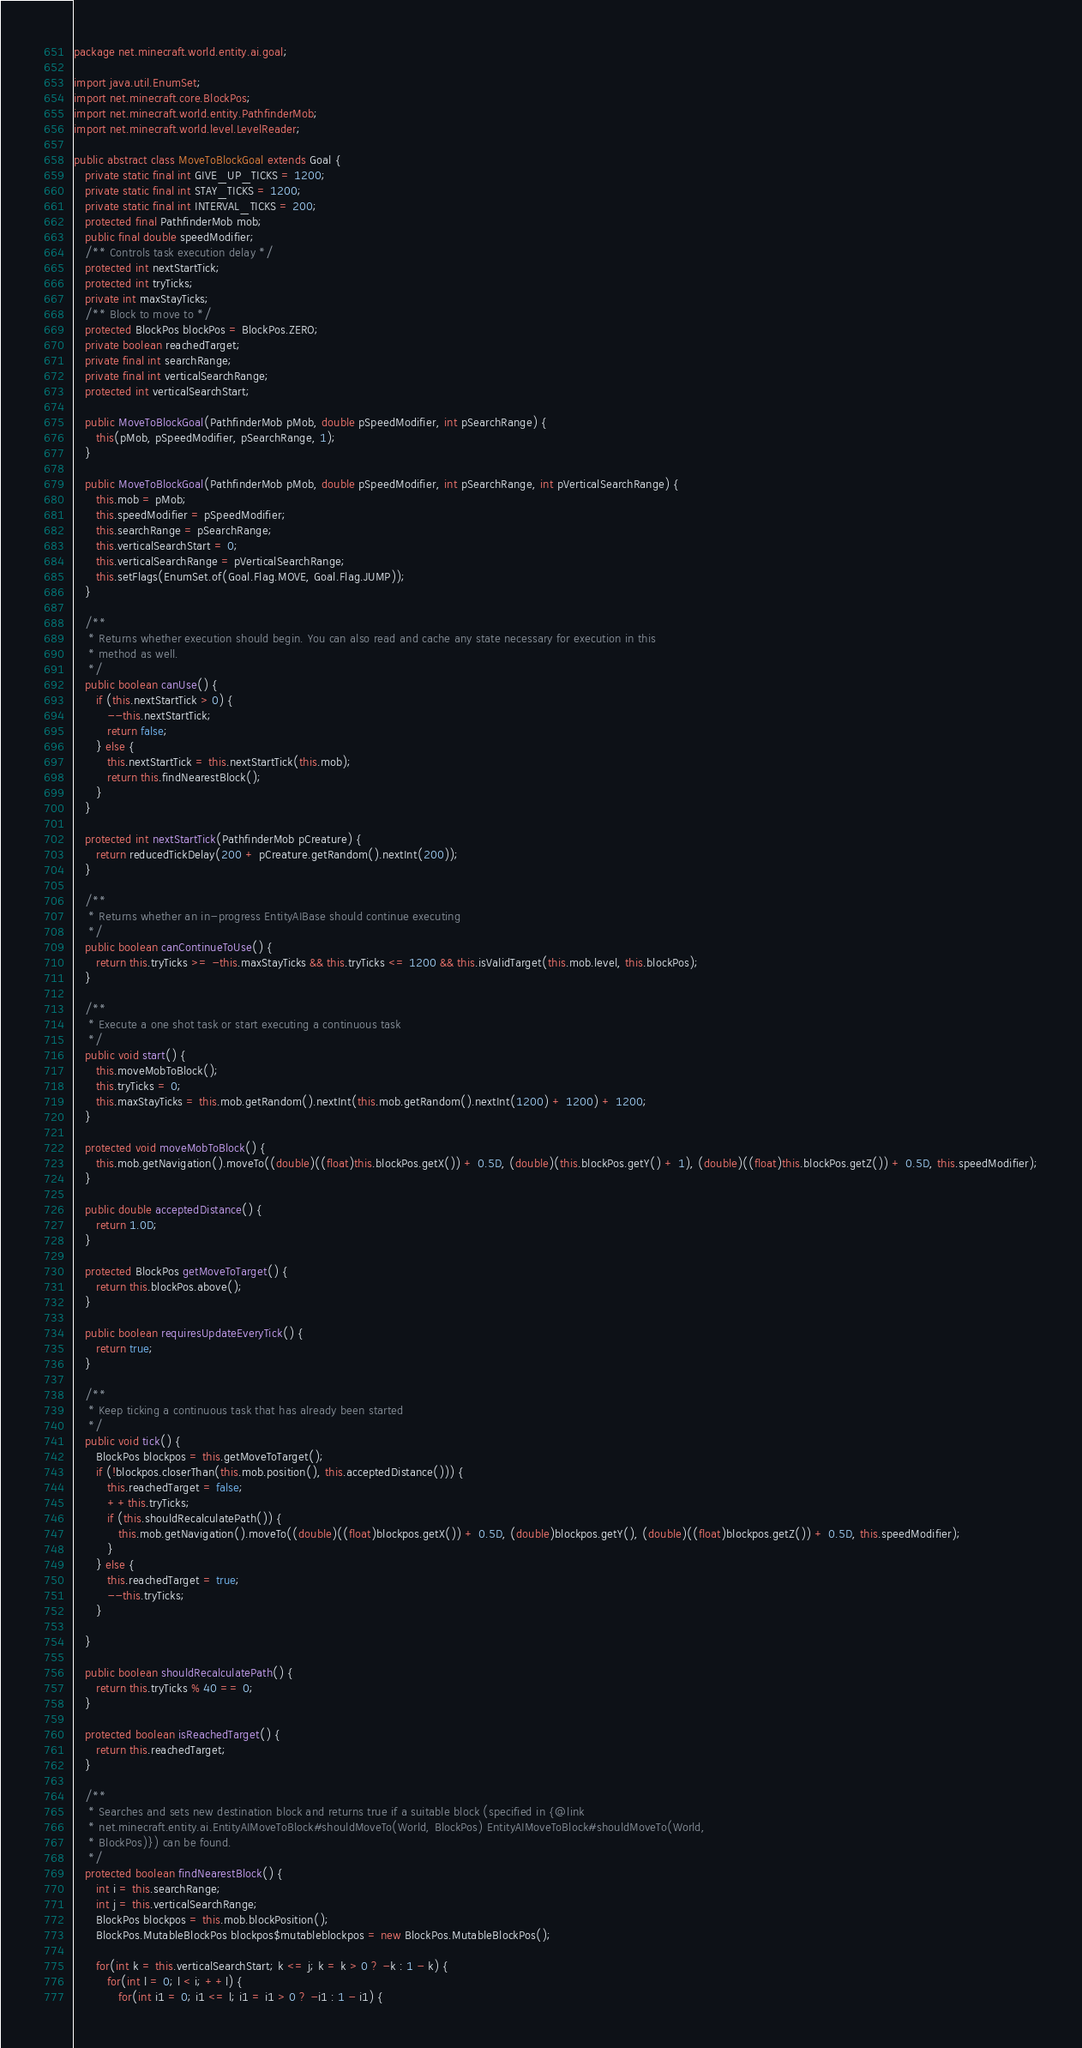<code> <loc_0><loc_0><loc_500><loc_500><_Java_>package net.minecraft.world.entity.ai.goal;

import java.util.EnumSet;
import net.minecraft.core.BlockPos;
import net.minecraft.world.entity.PathfinderMob;
import net.minecraft.world.level.LevelReader;

public abstract class MoveToBlockGoal extends Goal {
   private static final int GIVE_UP_TICKS = 1200;
   private static final int STAY_TICKS = 1200;
   private static final int INTERVAL_TICKS = 200;
   protected final PathfinderMob mob;
   public final double speedModifier;
   /** Controls task execution delay */
   protected int nextStartTick;
   protected int tryTicks;
   private int maxStayTicks;
   /** Block to move to */
   protected BlockPos blockPos = BlockPos.ZERO;
   private boolean reachedTarget;
   private final int searchRange;
   private final int verticalSearchRange;
   protected int verticalSearchStart;

   public MoveToBlockGoal(PathfinderMob pMob, double pSpeedModifier, int pSearchRange) {
      this(pMob, pSpeedModifier, pSearchRange, 1);
   }

   public MoveToBlockGoal(PathfinderMob pMob, double pSpeedModifier, int pSearchRange, int pVerticalSearchRange) {
      this.mob = pMob;
      this.speedModifier = pSpeedModifier;
      this.searchRange = pSearchRange;
      this.verticalSearchStart = 0;
      this.verticalSearchRange = pVerticalSearchRange;
      this.setFlags(EnumSet.of(Goal.Flag.MOVE, Goal.Flag.JUMP));
   }

   /**
    * Returns whether execution should begin. You can also read and cache any state necessary for execution in this
    * method as well.
    */
   public boolean canUse() {
      if (this.nextStartTick > 0) {
         --this.nextStartTick;
         return false;
      } else {
         this.nextStartTick = this.nextStartTick(this.mob);
         return this.findNearestBlock();
      }
   }

   protected int nextStartTick(PathfinderMob pCreature) {
      return reducedTickDelay(200 + pCreature.getRandom().nextInt(200));
   }

   /**
    * Returns whether an in-progress EntityAIBase should continue executing
    */
   public boolean canContinueToUse() {
      return this.tryTicks >= -this.maxStayTicks && this.tryTicks <= 1200 && this.isValidTarget(this.mob.level, this.blockPos);
   }

   /**
    * Execute a one shot task or start executing a continuous task
    */
   public void start() {
      this.moveMobToBlock();
      this.tryTicks = 0;
      this.maxStayTicks = this.mob.getRandom().nextInt(this.mob.getRandom().nextInt(1200) + 1200) + 1200;
   }

   protected void moveMobToBlock() {
      this.mob.getNavigation().moveTo((double)((float)this.blockPos.getX()) + 0.5D, (double)(this.blockPos.getY() + 1), (double)((float)this.blockPos.getZ()) + 0.5D, this.speedModifier);
   }

   public double acceptedDistance() {
      return 1.0D;
   }

   protected BlockPos getMoveToTarget() {
      return this.blockPos.above();
   }

   public boolean requiresUpdateEveryTick() {
      return true;
   }

   /**
    * Keep ticking a continuous task that has already been started
    */
   public void tick() {
      BlockPos blockpos = this.getMoveToTarget();
      if (!blockpos.closerThan(this.mob.position(), this.acceptedDistance())) {
         this.reachedTarget = false;
         ++this.tryTicks;
         if (this.shouldRecalculatePath()) {
            this.mob.getNavigation().moveTo((double)((float)blockpos.getX()) + 0.5D, (double)blockpos.getY(), (double)((float)blockpos.getZ()) + 0.5D, this.speedModifier);
         }
      } else {
         this.reachedTarget = true;
         --this.tryTicks;
      }

   }

   public boolean shouldRecalculatePath() {
      return this.tryTicks % 40 == 0;
   }

   protected boolean isReachedTarget() {
      return this.reachedTarget;
   }

   /**
    * Searches and sets new destination block and returns true if a suitable block (specified in {@link
    * net.minecraft.entity.ai.EntityAIMoveToBlock#shouldMoveTo(World, BlockPos) EntityAIMoveToBlock#shouldMoveTo(World,
    * BlockPos)}) can be found.
    */
   protected boolean findNearestBlock() {
      int i = this.searchRange;
      int j = this.verticalSearchRange;
      BlockPos blockpos = this.mob.blockPosition();
      BlockPos.MutableBlockPos blockpos$mutableblockpos = new BlockPos.MutableBlockPos();

      for(int k = this.verticalSearchStart; k <= j; k = k > 0 ? -k : 1 - k) {
         for(int l = 0; l < i; ++l) {
            for(int i1 = 0; i1 <= l; i1 = i1 > 0 ? -i1 : 1 - i1) {</code> 